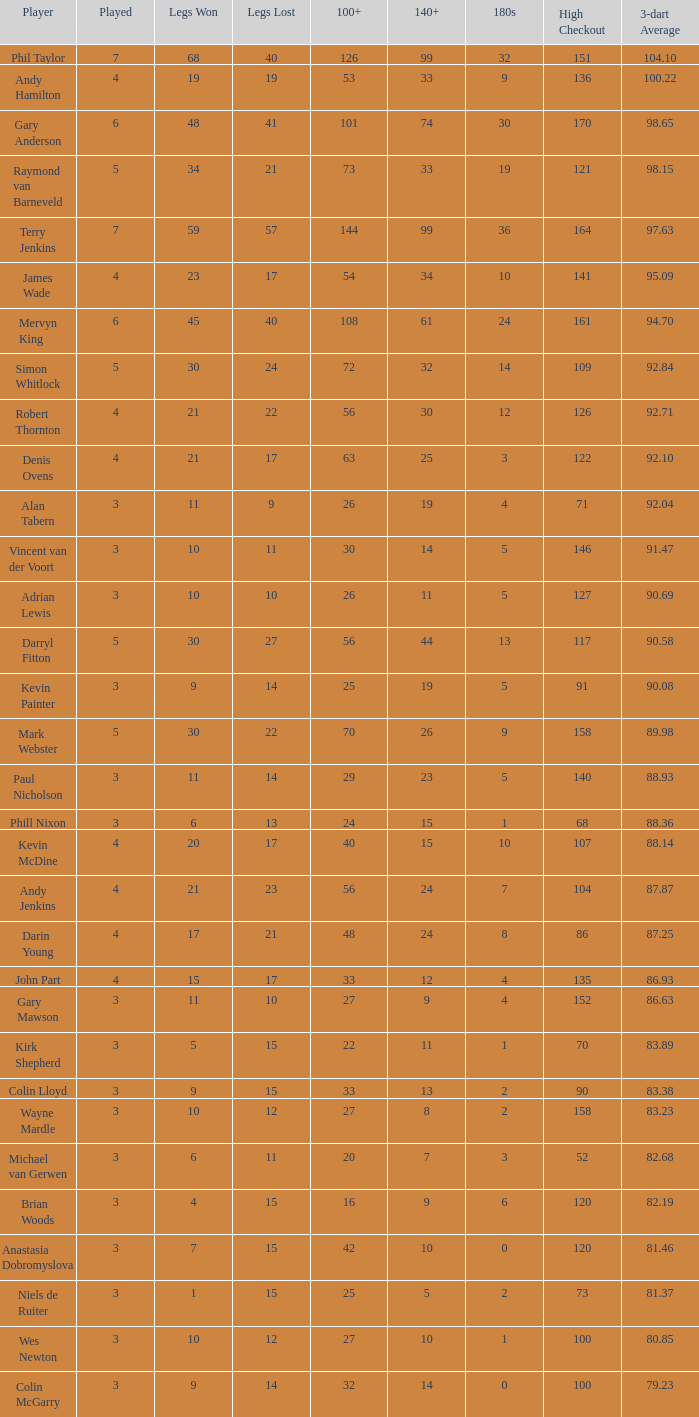What number is played if the high checkout is 135? 4.0. 